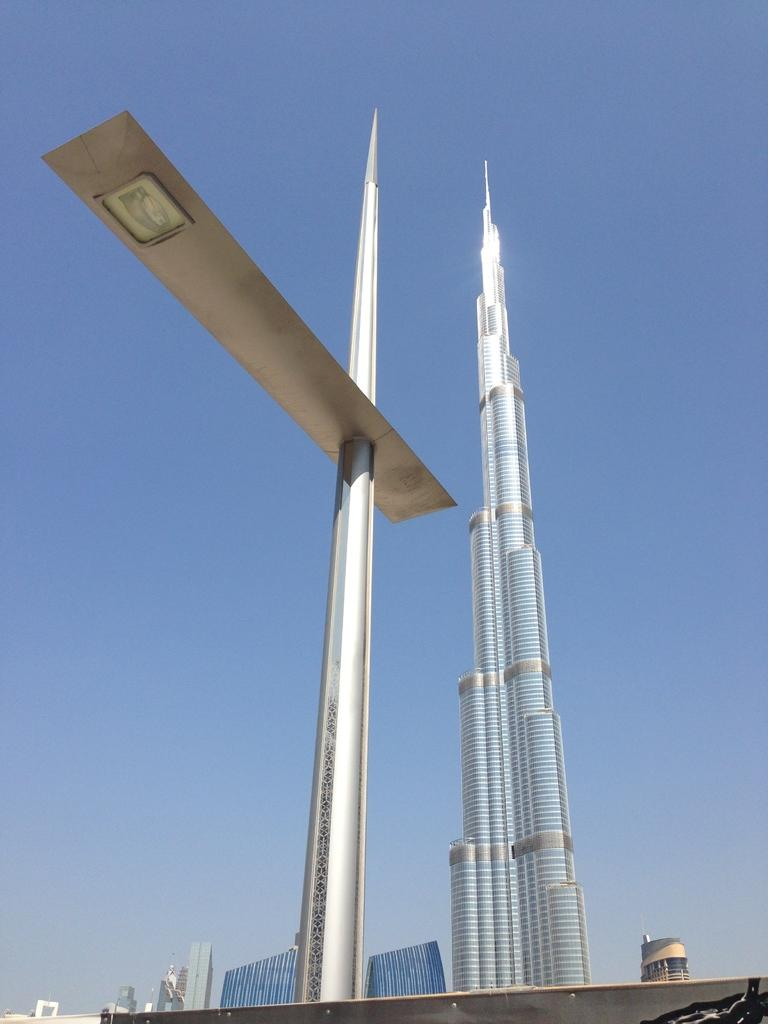What is attached to the pole in the image? There is an object attached to the pole in the image. What type of structure can be seen in the background of the image? There is a skyscraper and other buildings in the background of the image. What part of the natural environment is visible in the image? The sky is visible in the background of the image. What type of twig is being used to change the light bulb in the image? There is no light bulb or twig present in the image. 